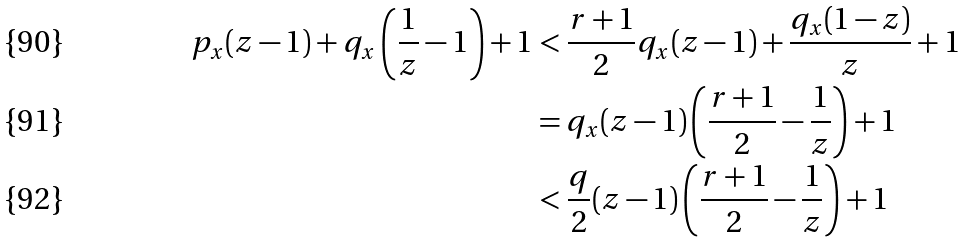<formula> <loc_0><loc_0><loc_500><loc_500>p _ { x } ( z - 1 ) + q _ { x } \left ( \frac { 1 } { z } - 1 \right ) + 1 & < \frac { r + 1 } { 2 } q _ { x } ( z - 1 ) + \frac { q _ { x } ( 1 - z ) } { z } + 1 \\ & = q _ { x } ( z - 1 ) \left ( \frac { r + 1 } { 2 } - \frac { 1 } { z } \right ) + 1 \\ & < \frac { q } { 2 } ( z - 1 ) \left ( \frac { r + 1 } { 2 } - \frac { 1 } { z } \right ) + 1</formula> 